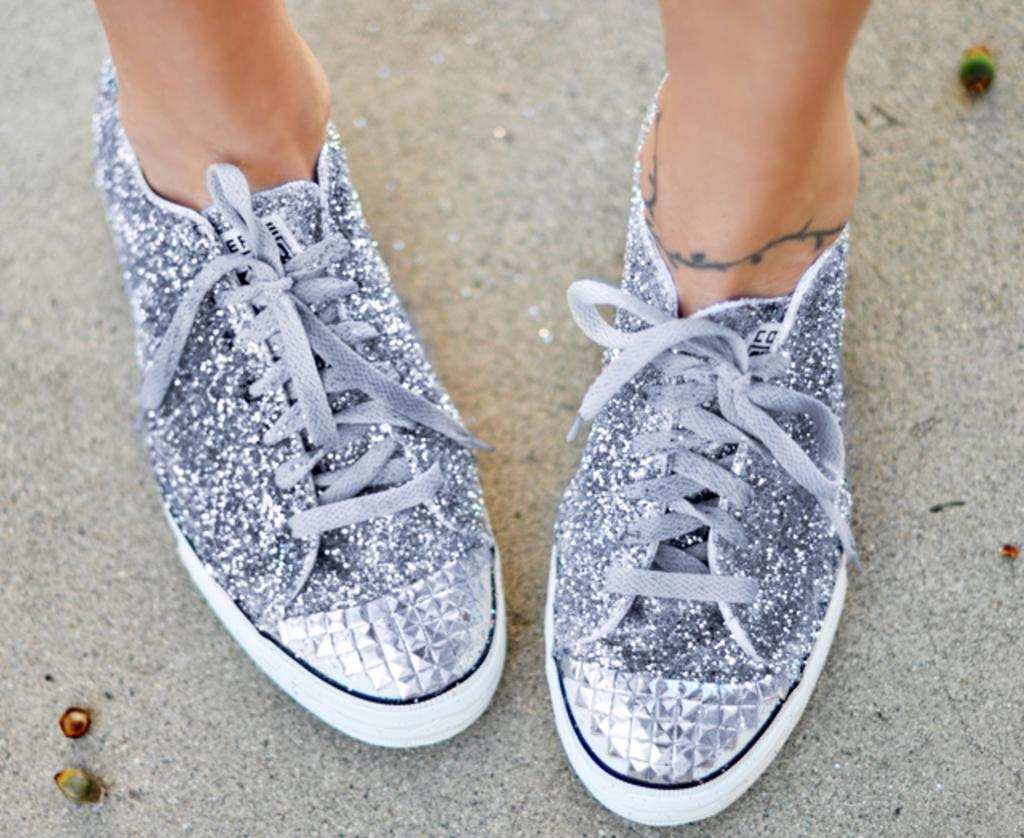What part of a woman's body is visible in the image? There are two legs of a woman in the image. What type of shoes is the woman wearing? The woman is wearing silver shoes. What type of surface is under the shoes in the image? There is sand under the shoes in the image. What type of yak can be seen in the image? There is no yak present in the image; it features a woman's legs and silver shoes on sand. Can you describe the design of the stranger's outfit in the image? There is no stranger present in the image, only a woman's legs and silver shoes on sand. 